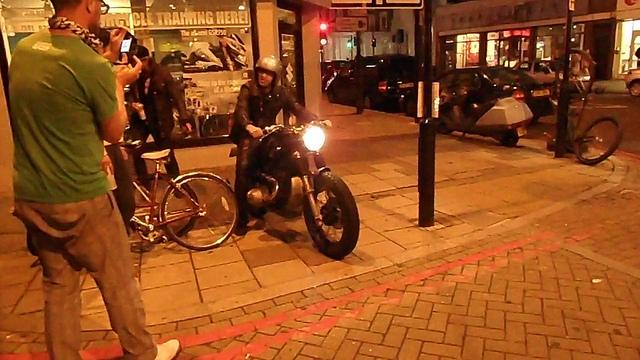What is aimed at the man on the motorcycle? Please explain your reasoning. camera. The camera is aimed. 